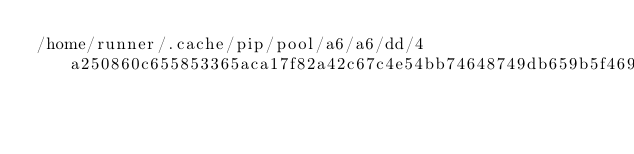Convert code to text. <code><loc_0><loc_0><loc_500><loc_500><_Python_>/home/runner/.cache/pip/pool/a6/a6/dd/4a250860c655853365aca17f82a42c67c4e54bb74648749db659b5f469</code> 